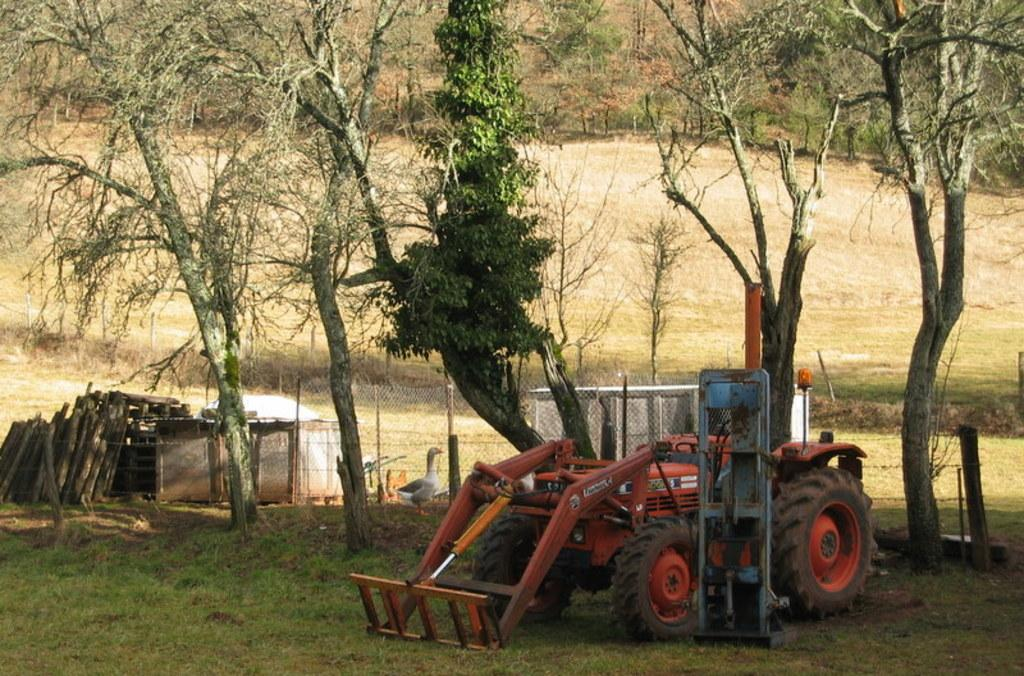What is the main subject of the image? There is a vehicle in the image. What can be seen on the left side of the image? There are logs on the left side of the image. What is visible in the background of the image? There are trees, sheds, and a mesh in the background of the image. Are there any animals present in the image? Yes, there is a duck in the image. What is the caption of the image? There is no caption present in the image. How many instruments can be seen in the image? There are no instruments visible in the image. 